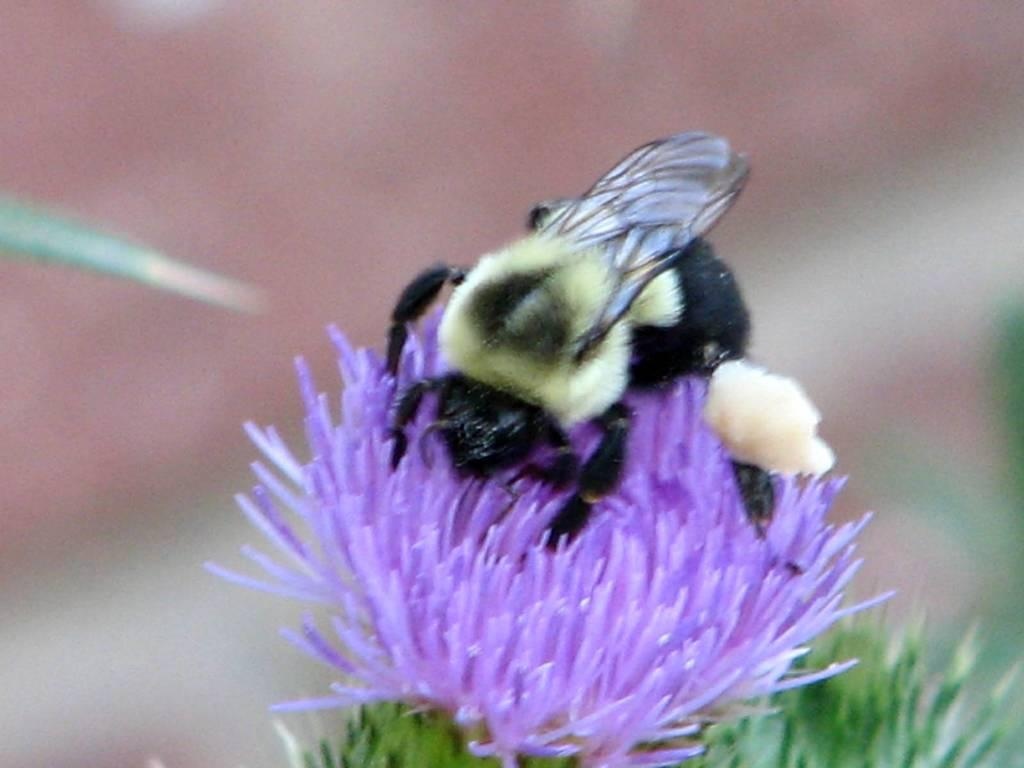What is the main subject of the image? There is an insect on a flower in the image. Can you describe the background of the image? The background of the image is blurred. What type of rake is being used to maintain the railway in the image? There is no rake or railway present in the image; it features an insect on a flower with a blurred background. What is the rate of the insect's movement in the image? The image is a still photograph, so the insect's movement cannot be determined. 